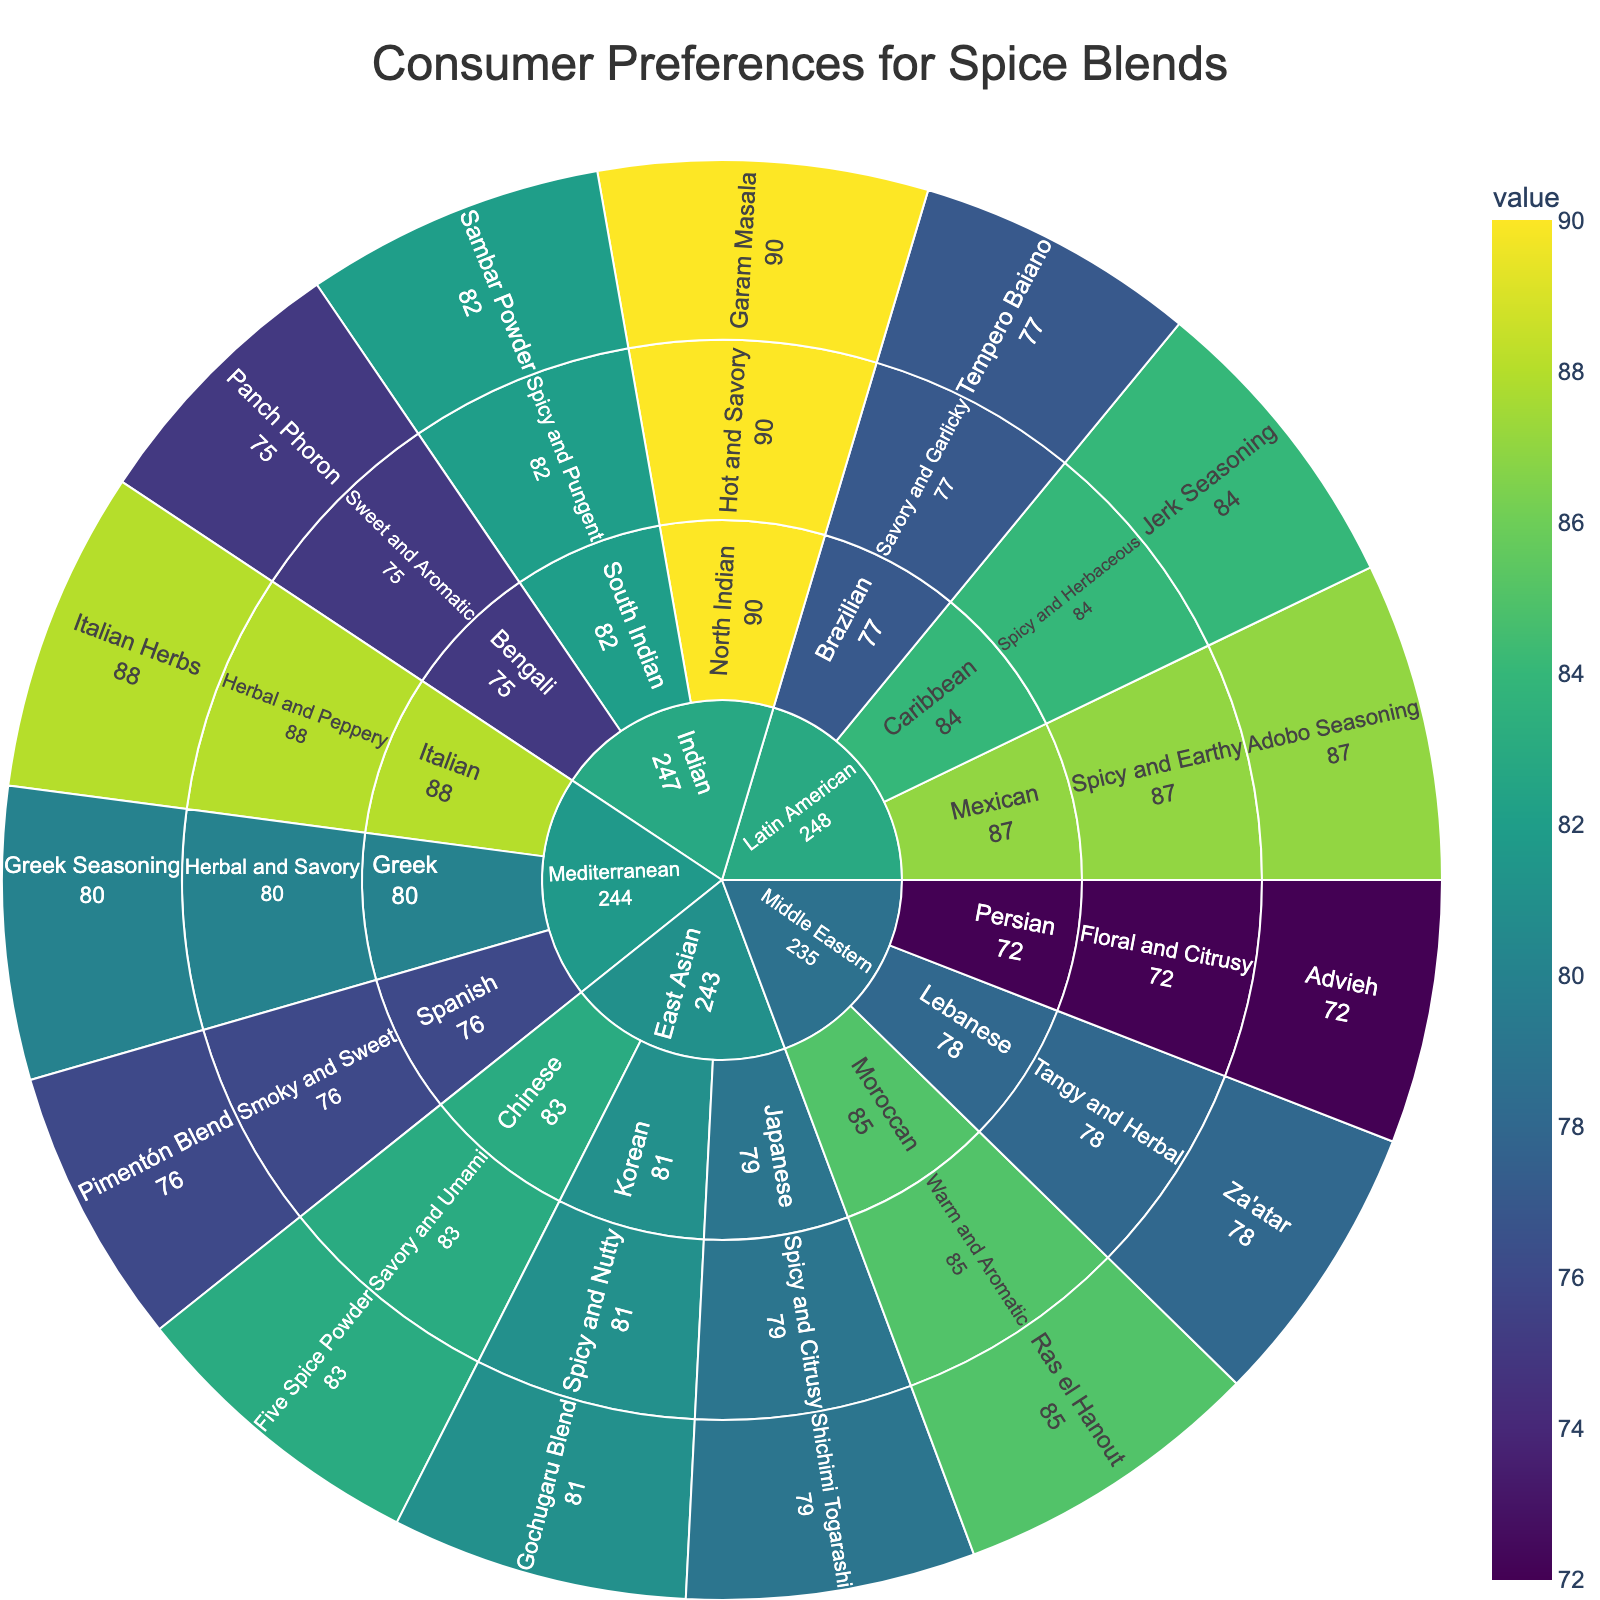What is the title of the plot? The title of the plot is displayed at the top of the figure in a larger font size.
Answer: Consumer Preferences for Spice Blends Which spice blend has the highest preference score? The preference scores are assigned to spice blends, represented as numerical values. Identify the highest number, which is 90, associated with Garam Masala.
Answer: Garam Masala How many subcategories are under the Middle Eastern category? The Middle Eastern category subdivides into three branches shown on the plot. Count these branches.
Answer: 3 What is the preference score for Za'atar? Locate Za'atar in the subcategory Lebanese under Middle Eastern. The associated preference score is visible next to it.
Answer: 78 What is the average preference score of all Indian spice blends? Sum the preference scores of Indian blends (90 for Garam Masala, 82 for Sambar Powder, 75 for Panch Phoron) and divide by the number of blends (3). (90 + 82 + 75)/3 = 247/3 = 82.33
Answer: 82.33 Comparing Middle Eastern and East Asian, which category has a higher preference score for its top-rated spice blend? Identify the highest preference scores in both categories: Middle Eastern (Ras el Hanout, 85) and East Asian (Five Spice Powder, 83). Compare the two values (85 > 83).
Answer: Middle Eastern Which flavor profile under Latin American has the lowest preference score? Examine each Latin American flavor profile’s preference scores: Mexican (87), Caribbean (84), and Brazilian (77). Identify the lowest score (77).
Answer: Savory and Garlicky In which subcategory does the spice blend Shichimi Togarashi belong? Locate Shichimi Togarashi in the plot. Follow the hierarchy back to its subcategory under the East Asian category.
Answer: Japanese What is the total preference score for all Mediterranean spice blends? Sum the preference scores of all Mediterranean blends (80 for Greek Seasoning, 88 for Italian Herbs, 76 for Pimentón Blend). 80 + 88 + 76 = 244
Answer: 244 What percentage of the total preference score does Ras el Hanout hold among all Middle Eastern spice blends? Calculate the total score for Middle Eastern (85 for Ras el Hanout, 78 for Za'atar, 72 for Advieh). Total = 235. Compute percentage (85/235 * 100). Approximately 36.17%
Answer: 36.17% 